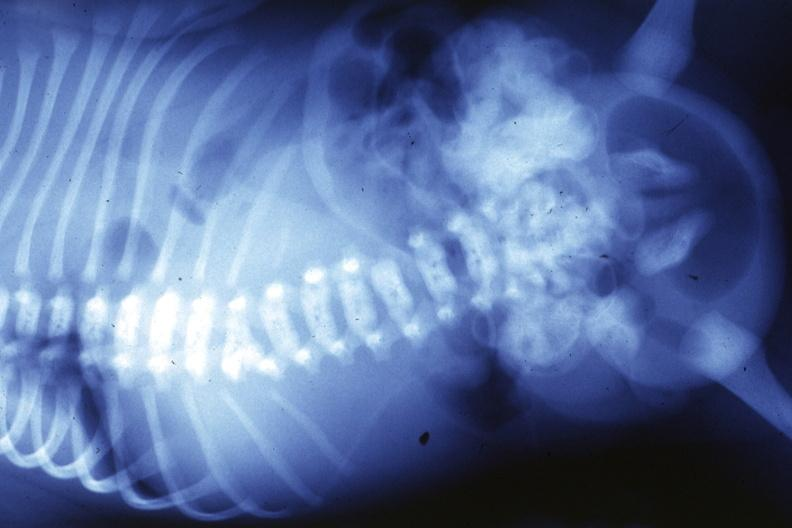s joints present?
Answer the question using a single word or phrase. Yes 